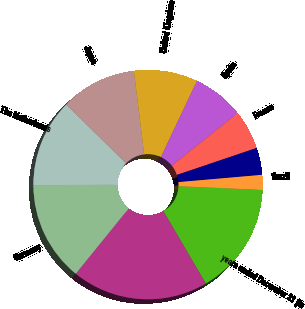Convert chart to OTSL. <chart><loc_0><loc_0><loc_500><loc_500><pie_chart><fcel>years ended December 31 (in<fcel>United States<fcel>Germany<fcel>The Netherlands<fcel>Japan<fcel>United Kingdom<fcel>Spain<fcel>France<fcel>Canada<fcel>Brazil<nl><fcel>15.84%<fcel>19.28%<fcel>14.12%<fcel>12.41%<fcel>10.69%<fcel>8.97%<fcel>7.25%<fcel>5.53%<fcel>3.81%<fcel>2.1%<nl></chart> 